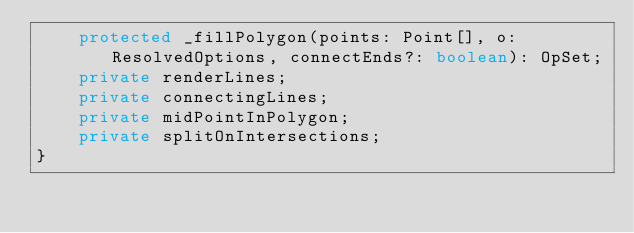<code> <loc_0><loc_0><loc_500><loc_500><_TypeScript_>    protected _fillPolygon(points: Point[], o: ResolvedOptions, connectEnds?: boolean): OpSet;
    private renderLines;
    private connectingLines;
    private midPointInPolygon;
    private splitOnIntersections;
}
</code> 